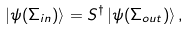Convert formula to latex. <formula><loc_0><loc_0><loc_500><loc_500>| \psi ( \Sigma _ { i n } ) \rangle = S ^ { \dagger } \, | \psi ( \Sigma _ { o u t } ) \rangle \, ,</formula> 